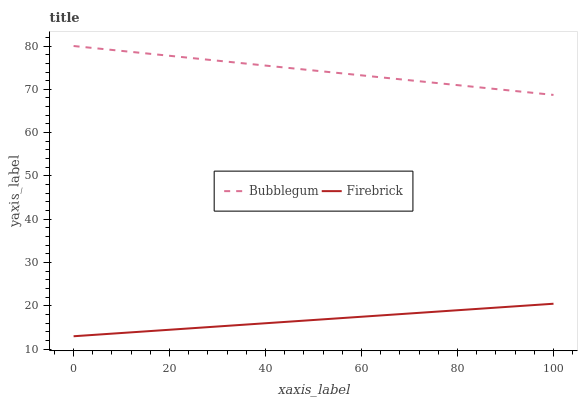Does Firebrick have the minimum area under the curve?
Answer yes or no. Yes. Does Bubblegum have the maximum area under the curve?
Answer yes or no. Yes. Does Bubblegum have the minimum area under the curve?
Answer yes or no. No. Is Firebrick the smoothest?
Answer yes or no. Yes. Is Bubblegum the roughest?
Answer yes or no. Yes. Is Bubblegum the smoothest?
Answer yes or no. No. Does Firebrick have the lowest value?
Answer yes or no. Yes. Does Bubblegum have the lowest value?
Answer yes or no. No. Does Bubblegum have the highest value?
Answer yes or no. Yes. Is Firebrick less than Bubblegum?
Answer yes or no. Yes. Is Bubblegum greater than Firebrick?
Answer yes or no. Yes. Does Firebrick intersect Bubblegum?
Answer yes or no. No. 